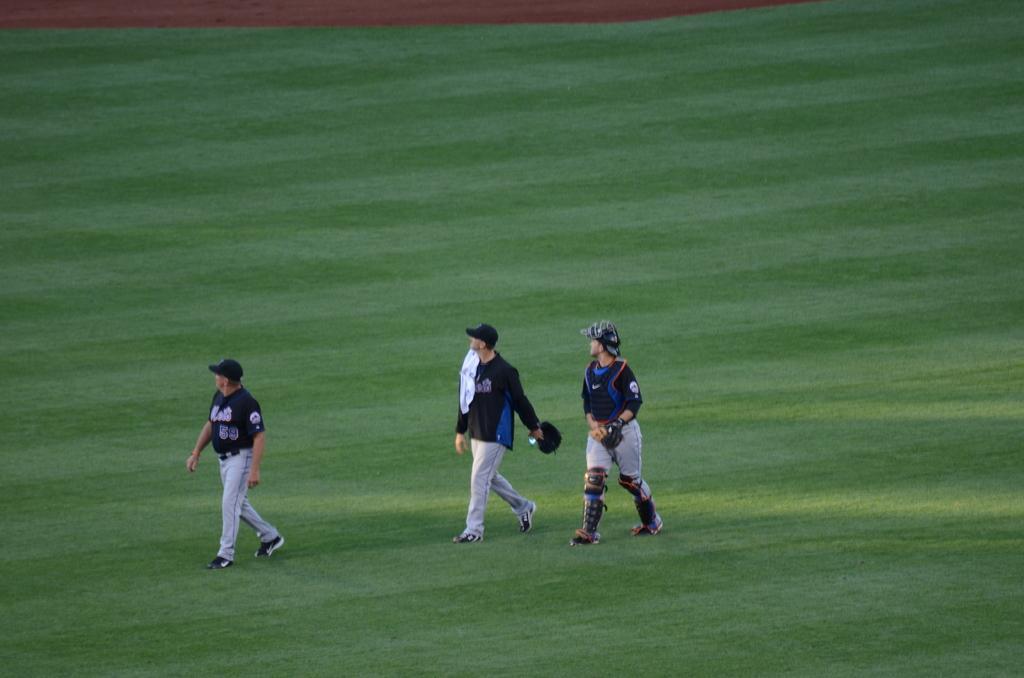In one or two sentences, can you explain what this image depicts? In this image there are three persons walking on the grass. 